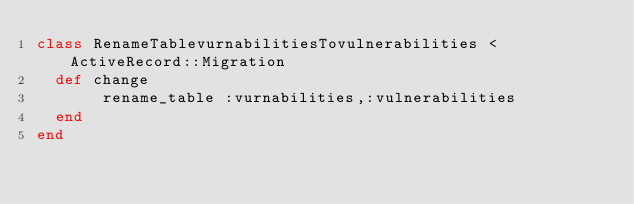<code> <loc_0><loc_0><loc_500><loc_500><_Ruby_>class RenameTablevurnabilitiesTovulnerabilities < ActiveRecord::Migration
  def change
       rename_table :vurnabilities,:vulnerabilities
  end
end
</code> 